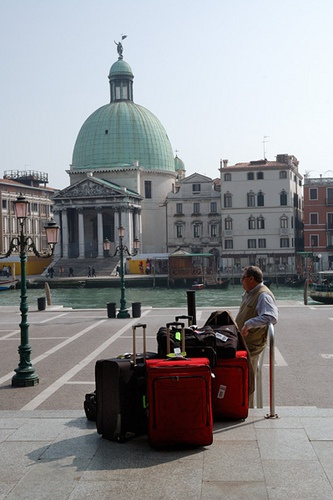Describe the objects in this image and their specific colors. I can see suitcase in lightgray, black, maroon, red, and brown tones, suitcase in lightgray, black, darkgray, gray, and maroon tones, people in lightgray, black, gray, maroon, and darkgray tones, suitcase in lightgray, black, maroon, and red tones, and suitcase in lightgray, black, gray, and darkgray tones in this image. 